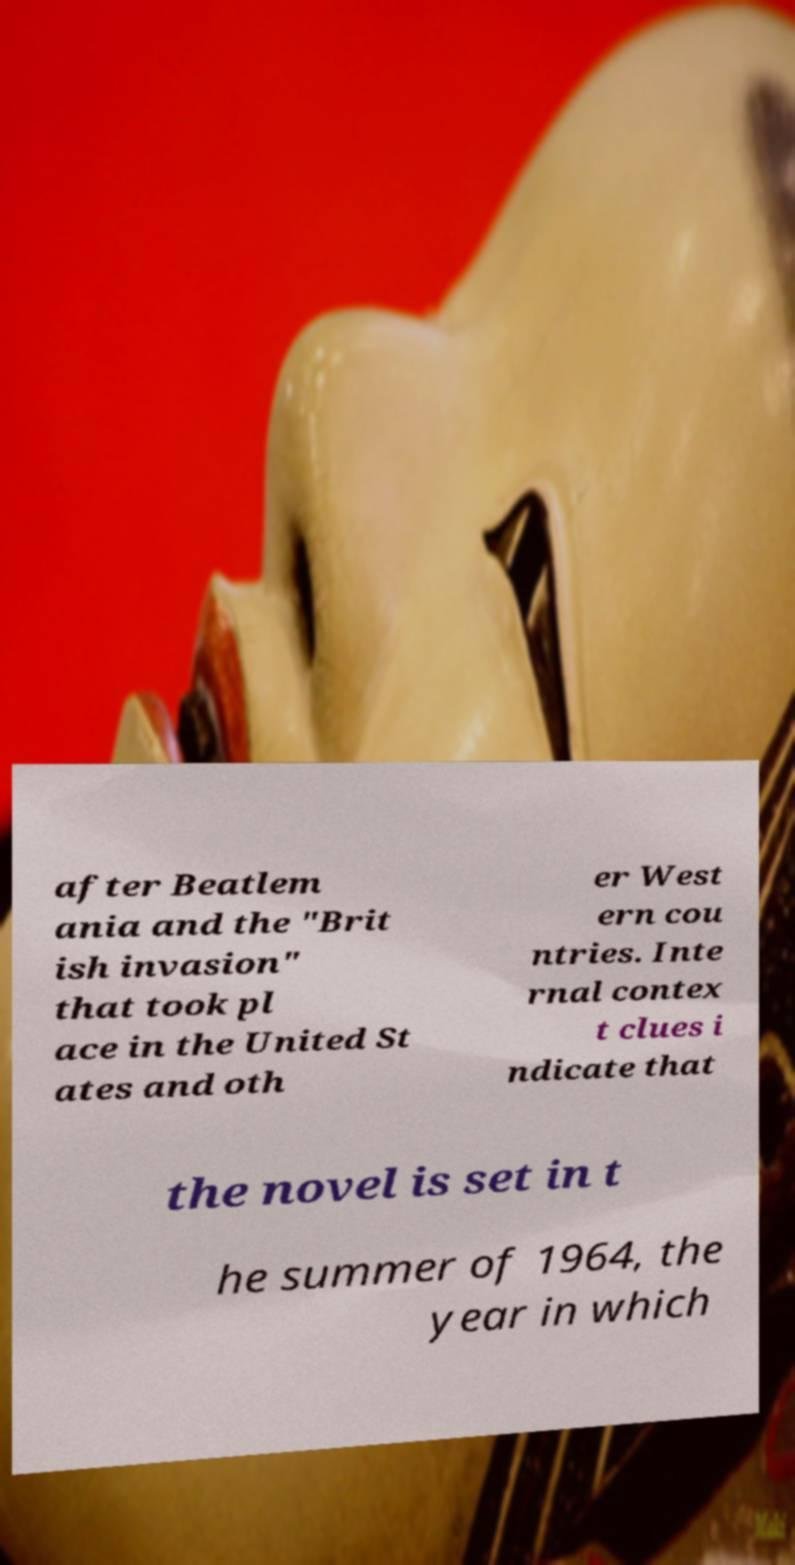For documentation purposes, I need the text within this image transcribed. Could you provide that? after Beatlem ania and the "Brit ish invasion" that took pl ace in the United St ates and oth er West ern cou ntries. Inte rnal contex t clues i ndicate that the novel is set in t he summer of 1964, the year in which 